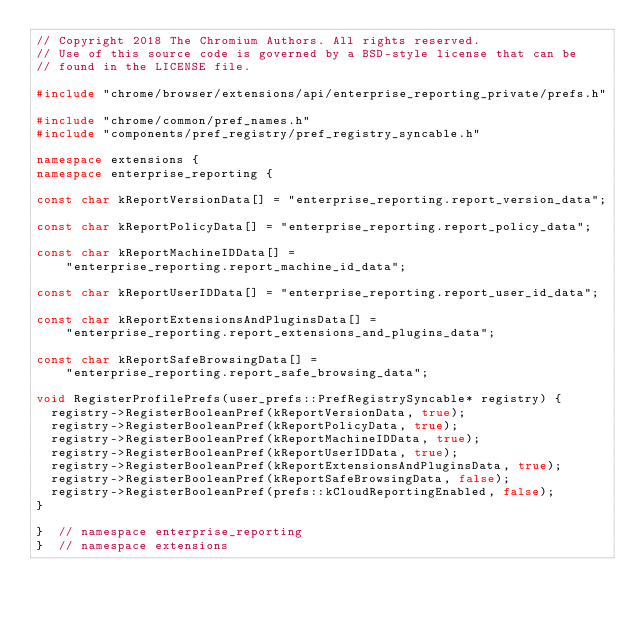Convert code to text. <code><loc_0><loc_0><loc_500><loc_500><_C++_>// Copyright 2018 The Chromium Authors. All rights reserved.
// Use of this source code is governed by a BSD-style license that can be
// found in the LICENSE file.

#include "chrome/browser/extensions/api/enterprise_reporting_private/prefs.h"

#include "chrome/common/pref_names.h"
#include "components/pref_registry/pref_registry_syncable.h"

namespace extensions {
namespace enterprise_reporting {

const char kReportVersionData[] = "enterprise_reporting.report_version_data";

const char kReportPolicyData[] = "enterprise_reporting.report_policy_data";

const char kReportMachineIDData[] =
    "enterprise_reporting.report_machine_id_data";

const char kReportUserIDData[] = "enterprise_reporting.report_user_id_data";

const char kReportExtensionsAndPluginsData[] =
    "enterprise_reporting.report_extensions_and_plugins_data";

const char kReportSafeBrowsingData[] =
    "enterprise_reporting.report_safe_browsing_data";

void RegisterProfilePrefs(user_prefs::PrefRegistrySyncable* registry) {
  registry->RegisterBooleanPref(kReportVersionData, true);
  registry->RegisterBooleanPref(kReportPolicyData, true);
  registry->RegisterBooleanPref(kReportMachineIDData, true);
  registry->RegisterBooleanPref(kReportUserIDData, true);
  registry->RegisterBooleanPref(kReportExtensionsAndPluginsData, true);
  registry->RegisterBooleanPref(kReportSafeBrowsingData, false);
  registry->RegisterBooleanPref(prefs::kCloudReportingEnabled, false);
}

}  // namespace enterprise_reporting
}  // namespace extensions
</code> 